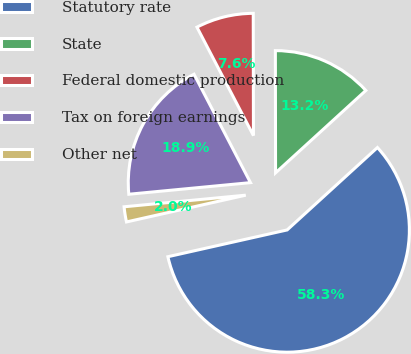Convert chart to OTSL. <chart><loc_0><loc_0><loc_500><loc_500><pie_chart><fcel>Statutory rate<fcel>State<fcel>Federal domestic production<fcel>Tax on foreign earnings<fcel>Other net<nl><fcel>58.26%<fcel>13.25%<fcel>7.62%<fcel>18.87%<fcel>2.0%<nl></chart> 